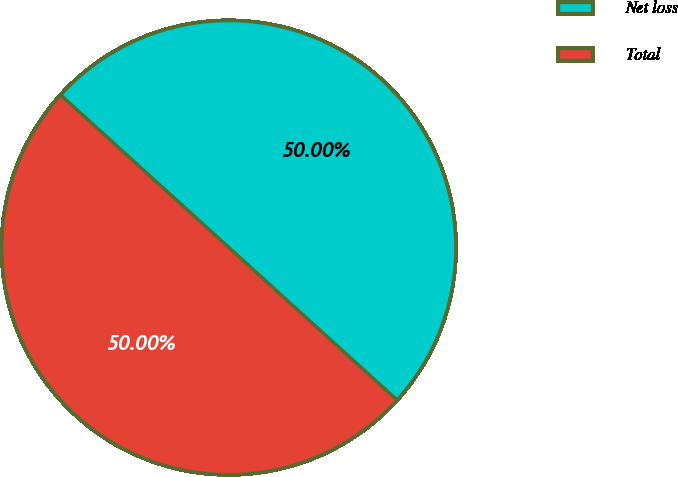Convert chart. <chart><loc_0><loc_0><loc_500><loc_500><pie_chart><fcel>Net loss<fcel>Total<nl><fcel>50.0%<fcel>50.0%<nl></chart> 